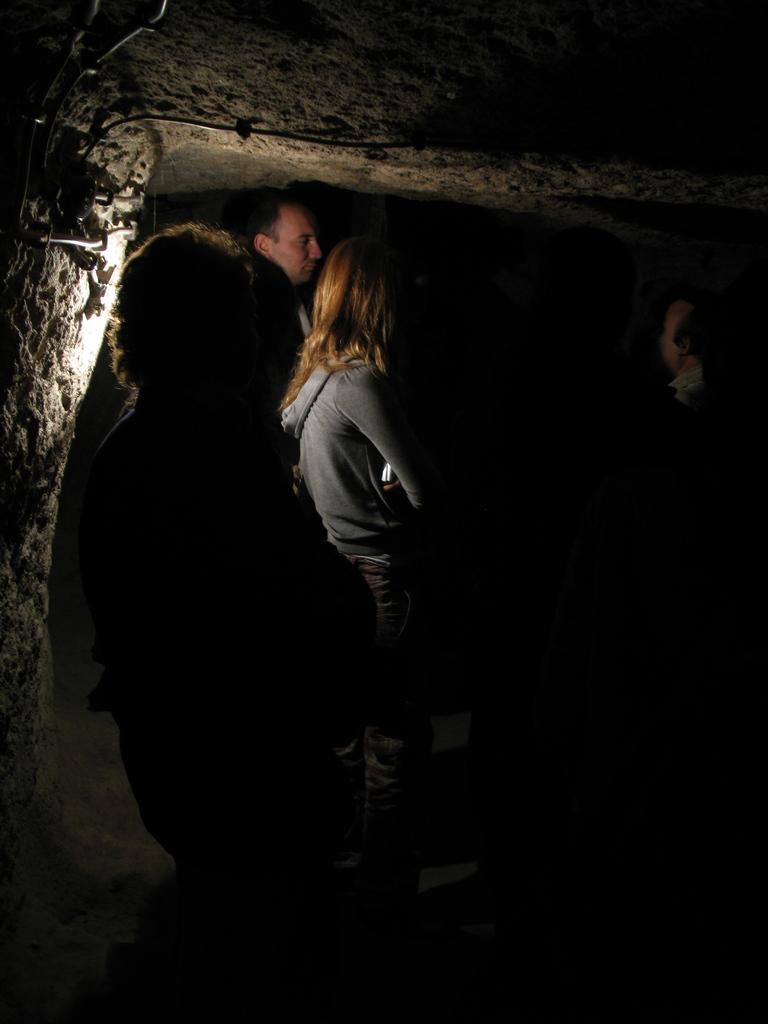How many people are in the image? There is a group of people in the image. What are the people wearing? The people are wearing dresses. What can be seen in the background of the image? There is a wall visible in the background of the image. What is on the right side of the image? There is a black image or object on the right side of the image. Can you tell me how much force the squirrel is exerting on the quarter in the image? There is no squirrel or quarter present in the image, so it is not possible to determine the force being exerted. 